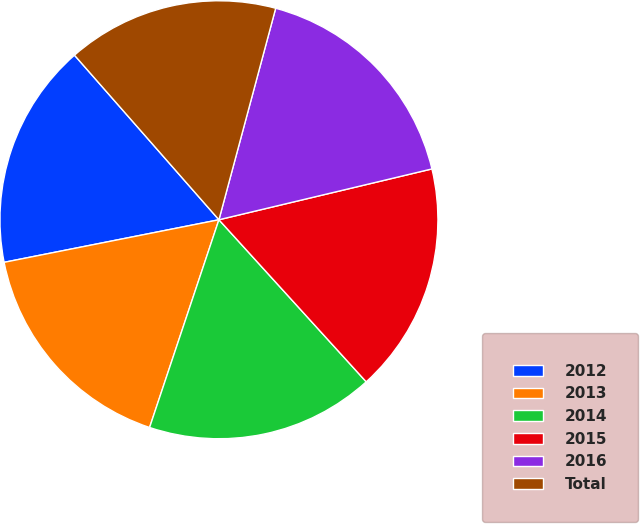Convert chart. <chart><loc_0><loc_0><loc_500><loc_500><pie_chart><fcel>2012<fcel>2013<fcel>2014<fcel>2015<fcel>2016<fcel>Total<nl><fcel>16.65%<fcel>16.76%<fcel>16.87%<fcel>16.99%<fcel>17.1%<fcel>15.64%<nl></chart> 